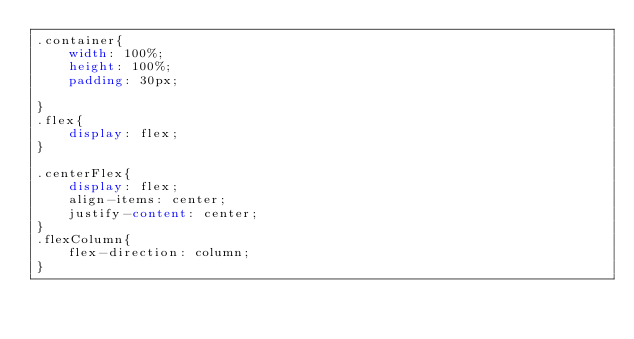<code> <loc_0><loc_0><loc_500><loc_500><_CSS_>.container{
    width: 100%;
    height: 100%;
    padding: 30px;
    
}
.flex{
    display: flex;
}

.centerFlex{
    display: flex;
    align-items: center;
    justify-content: center;
}
.flexColumn{
    flex-direction: column;
}</code> 